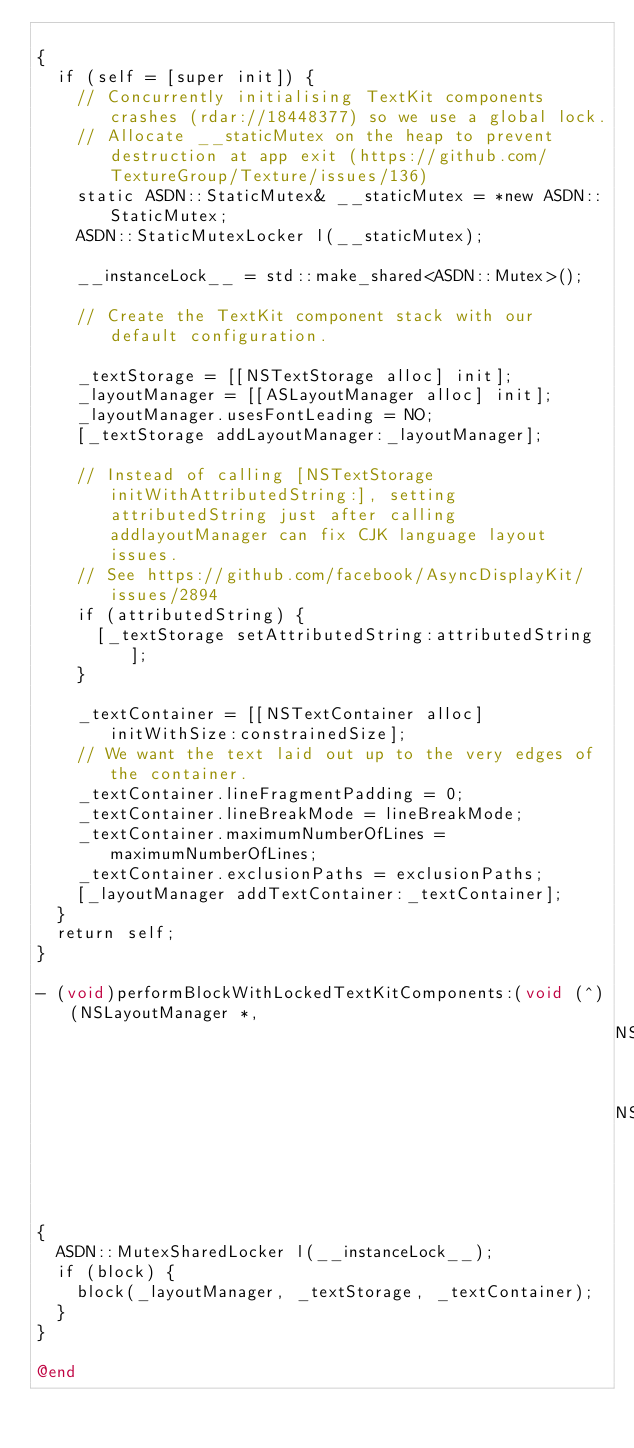Convert code to text. <code><loc_0><loc_0><loc_500><loc_500><_ObjectiveC_>
{
  if (self = [super init]) {
    // Concurrently initialising TextKit components crashes (rdar://18448377) so we use a global lock.
    // Allocate __staticMutex on the heap to prevent destruction at app exit (https://github.com/TextureGroup/Texture/issues/136)
    static ASDN::StaticMutex& __staticMutex = *new ASDN::StaticMutex;
    ASDN::StaticMutexLocker l(__staticMutex);
    
    __instanceLock__ = std::make_shared<ASDN::Mutex>();
    
    // Create the TextKit component stack with our default configuration.
    
    _textStorage = [[NSTextStorage alloc] init];
    _layoutManager = [[ASLayoutManager alloc] init];
    _layoutManager.usesFontLeading = NO;
    [_textStorage addLayoutManager:_layoutManager];
    
    // Instead of calling [NSTextStorage initWithAttributedString:], setting attributedString just after calling addlayoutManager can fix CJK language layout issues.
    // See https://github.com/facebook/AsyncDisplayKit/issues/2894
    if (attributedString) {
      [_textStorage setAttributedString:attributedString];
    }
    
    _textContainer = [[NSTextContainer alloc] initWithSize:constrainedSize];
    // We want the text laid out up to the very edges of the container.
    _textContainer.lineFragmentPadding = 0;
    _textContainer.lineBreakMode = lineBreakMode;
    _textContainer.maximumNumberOfLines = maximumNumberOfLines;
    _textContainer.exclusionPaths = exclusionPaths;
    [_layoutManager addTextContainer:_textContainer];
  }
  return self;
}

- (void)performBlockWithLockedTextKitComponents:(void (^)(NSLayoutManager *,
                                                          NSTextStorage *,
                                                          NSTextContainer *))block
{
  ASDN::MutexSharedLocker l(__instanceLock__);
  if (block) {
    block(_layoutManager, _textStorage, _textContainer);
  }
}

@end
</code> 